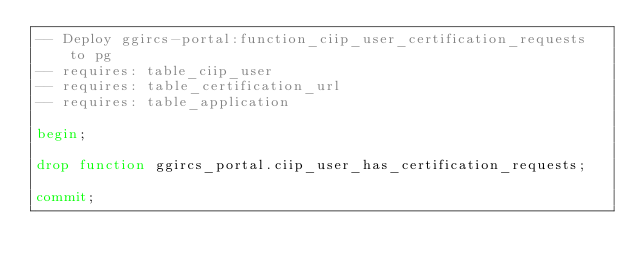<code> <loc_0><loc_0><loc_500><loc_500><_SQL_>-- Deploy ggircs-portal:function_ciip_user_certification_requests to pg
-- requires: table_ciip_user
-- requires: table_certification_url
-- requires: table_application

begin;

drop function ggircs_portal.ciip_user_has_certification_requests;

commit;
</code> 